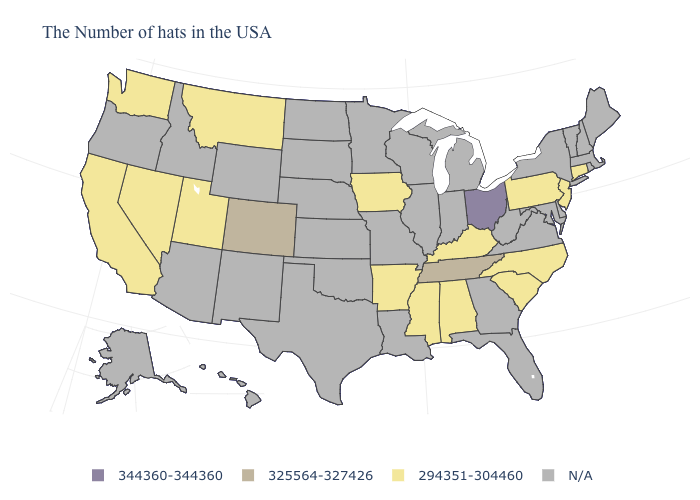Name the states that have a value in the range 294351-304460?
Concise answer only. Connecticut, New Jersey, Pennsylvania, North Carolina, South Carolina, Kentucky, Alabama, Mississippi, Arkansas, Iowa, Utah, Montana, Nevada, California, Washington. What is the value of Alaska?
Keep it brief. N/A. Name the states that have a value in the range N/A?
Answer briefly. Maine, Massachusetts, Rhode Island, New Hampshire, Vermont, New York, Delaware, Maryland, Virginia, West Virginia, Florida, Georgia, Michigan, Indiana, Wisconsin, Illinois, Louisiana, Missouri, Minnesota, Kansas, Nebraska, Oklahoma, Texas, South Dakota, North Dakota, Wyoming, New Mexico, Arizona, Idaho, Oregon, Alaska, Hawaii. Name the states that have a value in the range 325564-327426?
Short answer required. Tennessee, Colorado. Name the states that have a value in the range N/A?
Be succinct. Maine, Massachusetts, Rhode Island, New Hampshire, Vermont, New York, Delaware, Maryland, Virginia, West Virginia, Florida, Georgia, Michigan, Indiana, Wisconsin, Illinois, Louisiana, Missouri, Minnesota, Kansas, Nebraska, Oklahoma, Texas, South Dakota, North Dakota, Wyoming, New Mexico, Arizona, Idaho, Oregon, Alaska, Hawaii. Does the first symbol in the legend represent the smallest category?
Keep it brief. No. Which states have the lowest value in the MidWest?
Be succinct. Iowa. What is the value of Wisconsin?
Keep it brief. N/A. What is the highest value in the USA?
Keep it brief. 344360-344360. Which states have the lowest value in the USA?
Keep it brief. Connecticut, New Jersey, Pennsylvania, North Carolina, South Carolina, Kentucky, Alabama, Mississippi, Arkansas, Iowa, Utah, Montana, Nevada, California, Washington. Which states have the lowest value in the USA?
Give a very brief answer. Connecticut, New Jersey, Pennsylvania, North Carolina, South Carolina, Kentucky, Alabama, Mississippi, Arkansas, Iowa, Utah, Montana, Nevada, California, Washington. Among the states that border Maryland , which have the lowest value?
Concise answer only. Pennsylvania. Name the states that have a value in the range 344360-344360?
Write a very short answer. Ohio. What is the lowest value in states that border California?
Give a very brief answer. 294351-304460. What is the value of Illinois?
Keep it brief. N/A. 